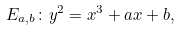Convert formula to latex. <formula><loc_0><loc_0><loc_500><loc_500>E _ { a , b } \colon y ^ { 2 } = x ^ { 3 } + a x + b ,</formula> 